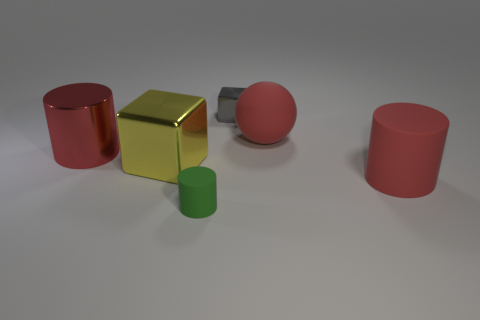Are there the same number of large yellow metal cubes that are to the right of the green matte thing and red rubber things?
Give a very brief answer. No. There is a sphere that is the same color as the large metal cylinder; what is its material?
Your answer should be compact. Rubber. Do the red metal thing and the red matte thing that is behind the big red shiny cylinder have the same size?
Offer a terse response. Yes. How many other objects are the same size as the red rubber cylinder?
Provide a succinct answer. 3. What number of other objects are there of the same color as the small metal object?
Give a very brief answer. 0. Are there any other things that have the same size as the yellow block?
Offer a terse response. Yes. How many other objects are the same shape as the gray metal thing?
Provide a short and direct response. 1. Do the yellow metal block and the gray metal thing have the same size?
Your answer should be very brief. No. Is there a purple thing?
Your answer should be very brief. No. Is there anything else that has the same material as the ball?
Your answer should be compact. Yes. 